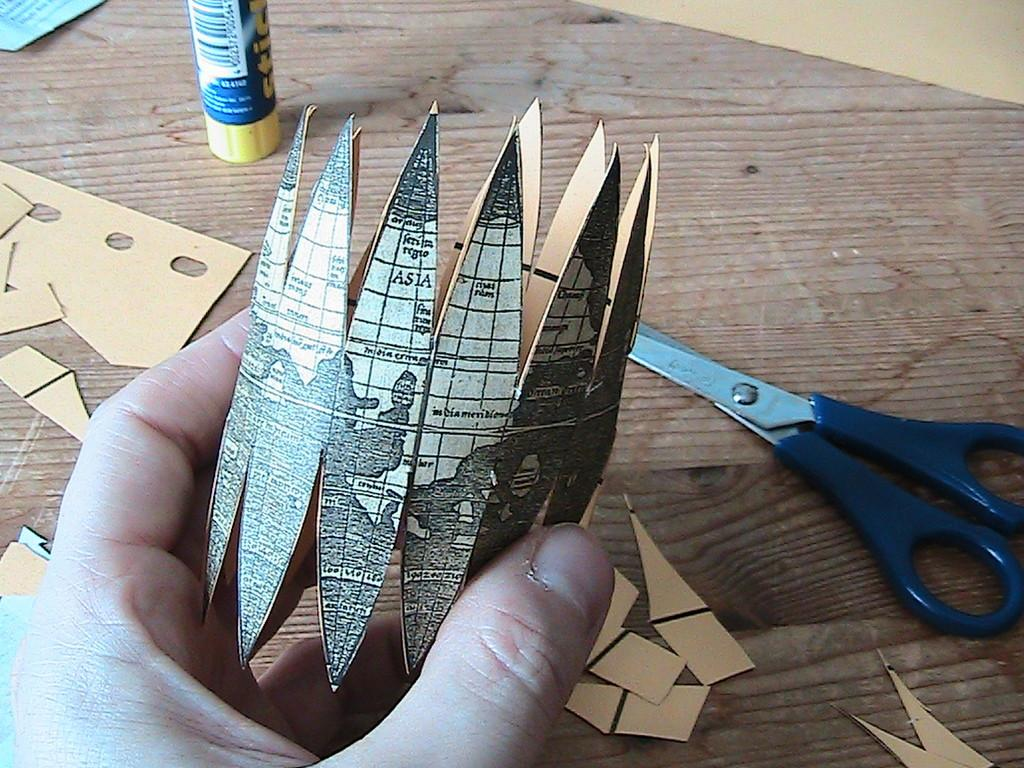What is the person holding in the image? The hand of a person is holding an object in the image. What can be seen on the table in the image? There are papers, a glue stick, and a pair of scissors on the table. What might be used for cutting in the image? The pair of scissors on the table can be used for cutting. How many dolls are sitting on the table in the image? There are no dolls present in the image. 